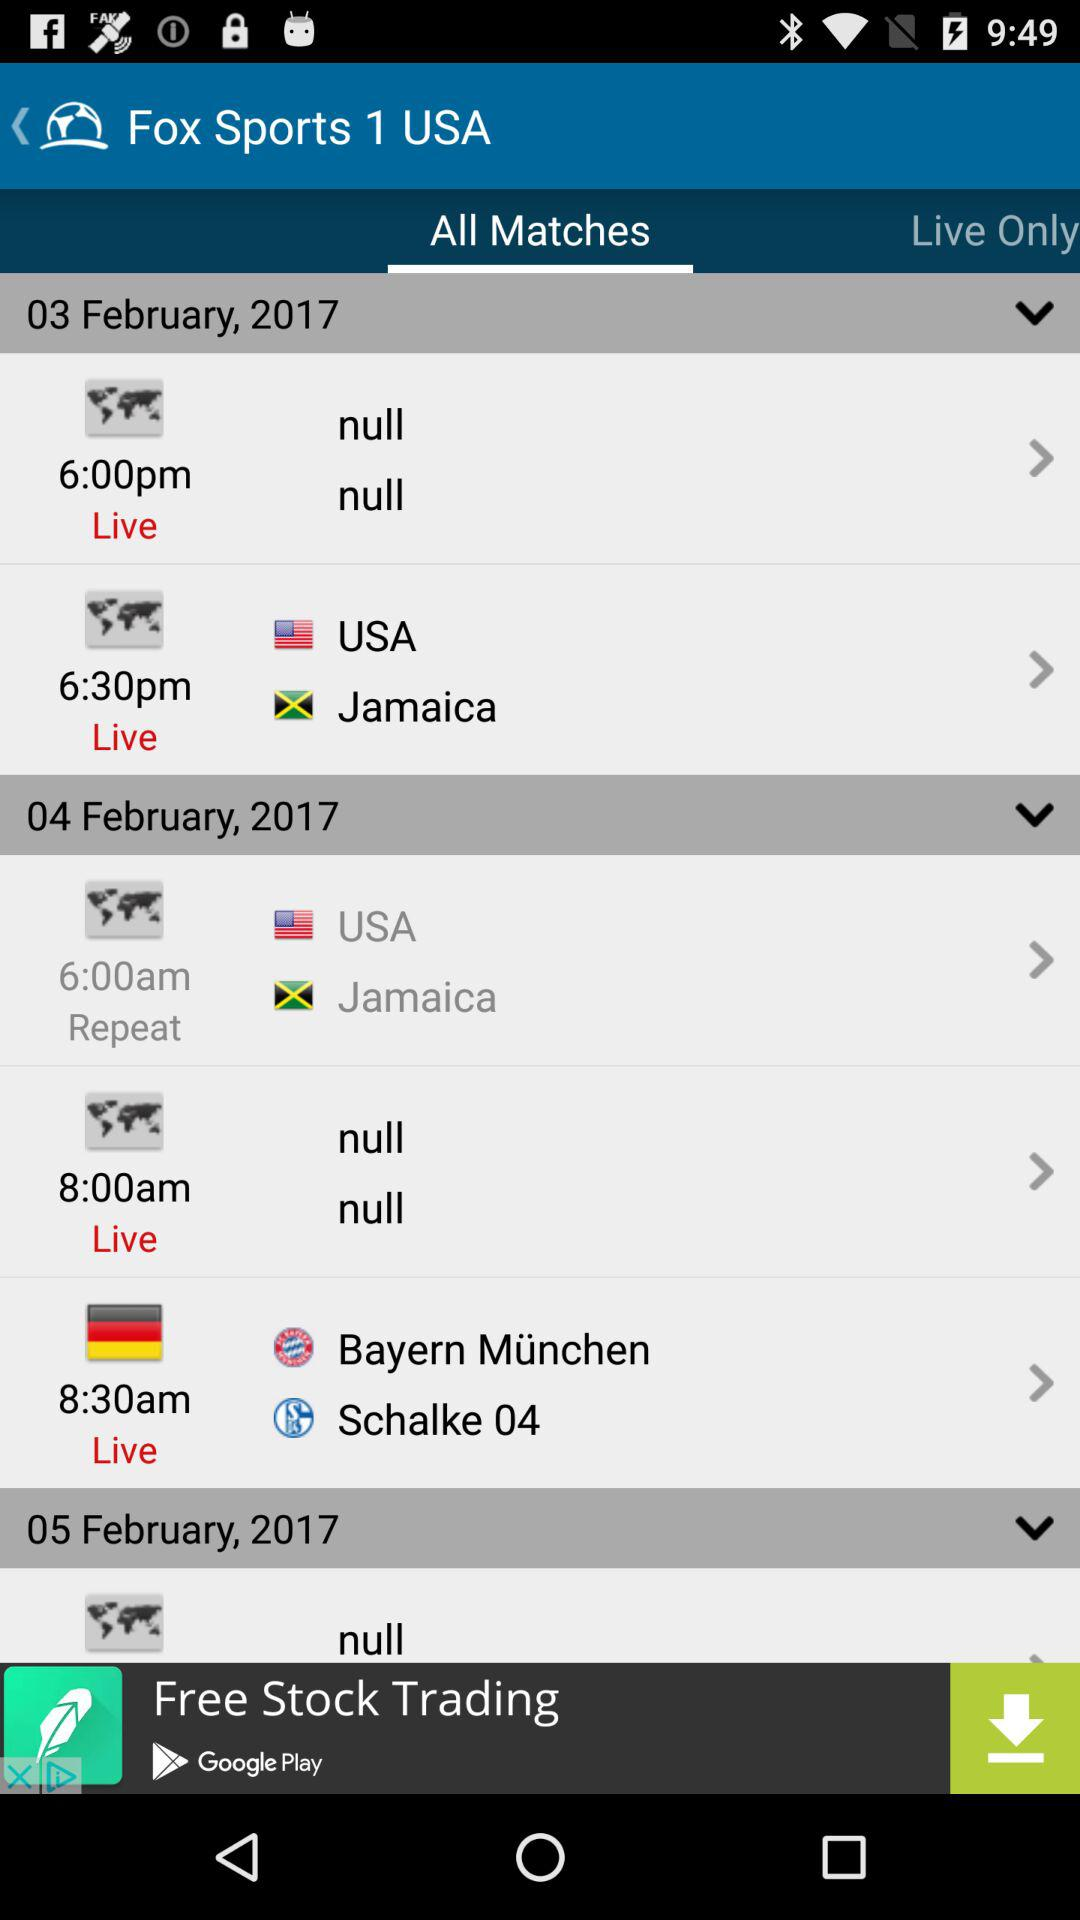What is the time of the repeat telecast of the match played between the "USA" and "Jamaica"? The time of the repeat telecast of the match played between the "USA" and "Jamaica" is 6:00 a.m. 